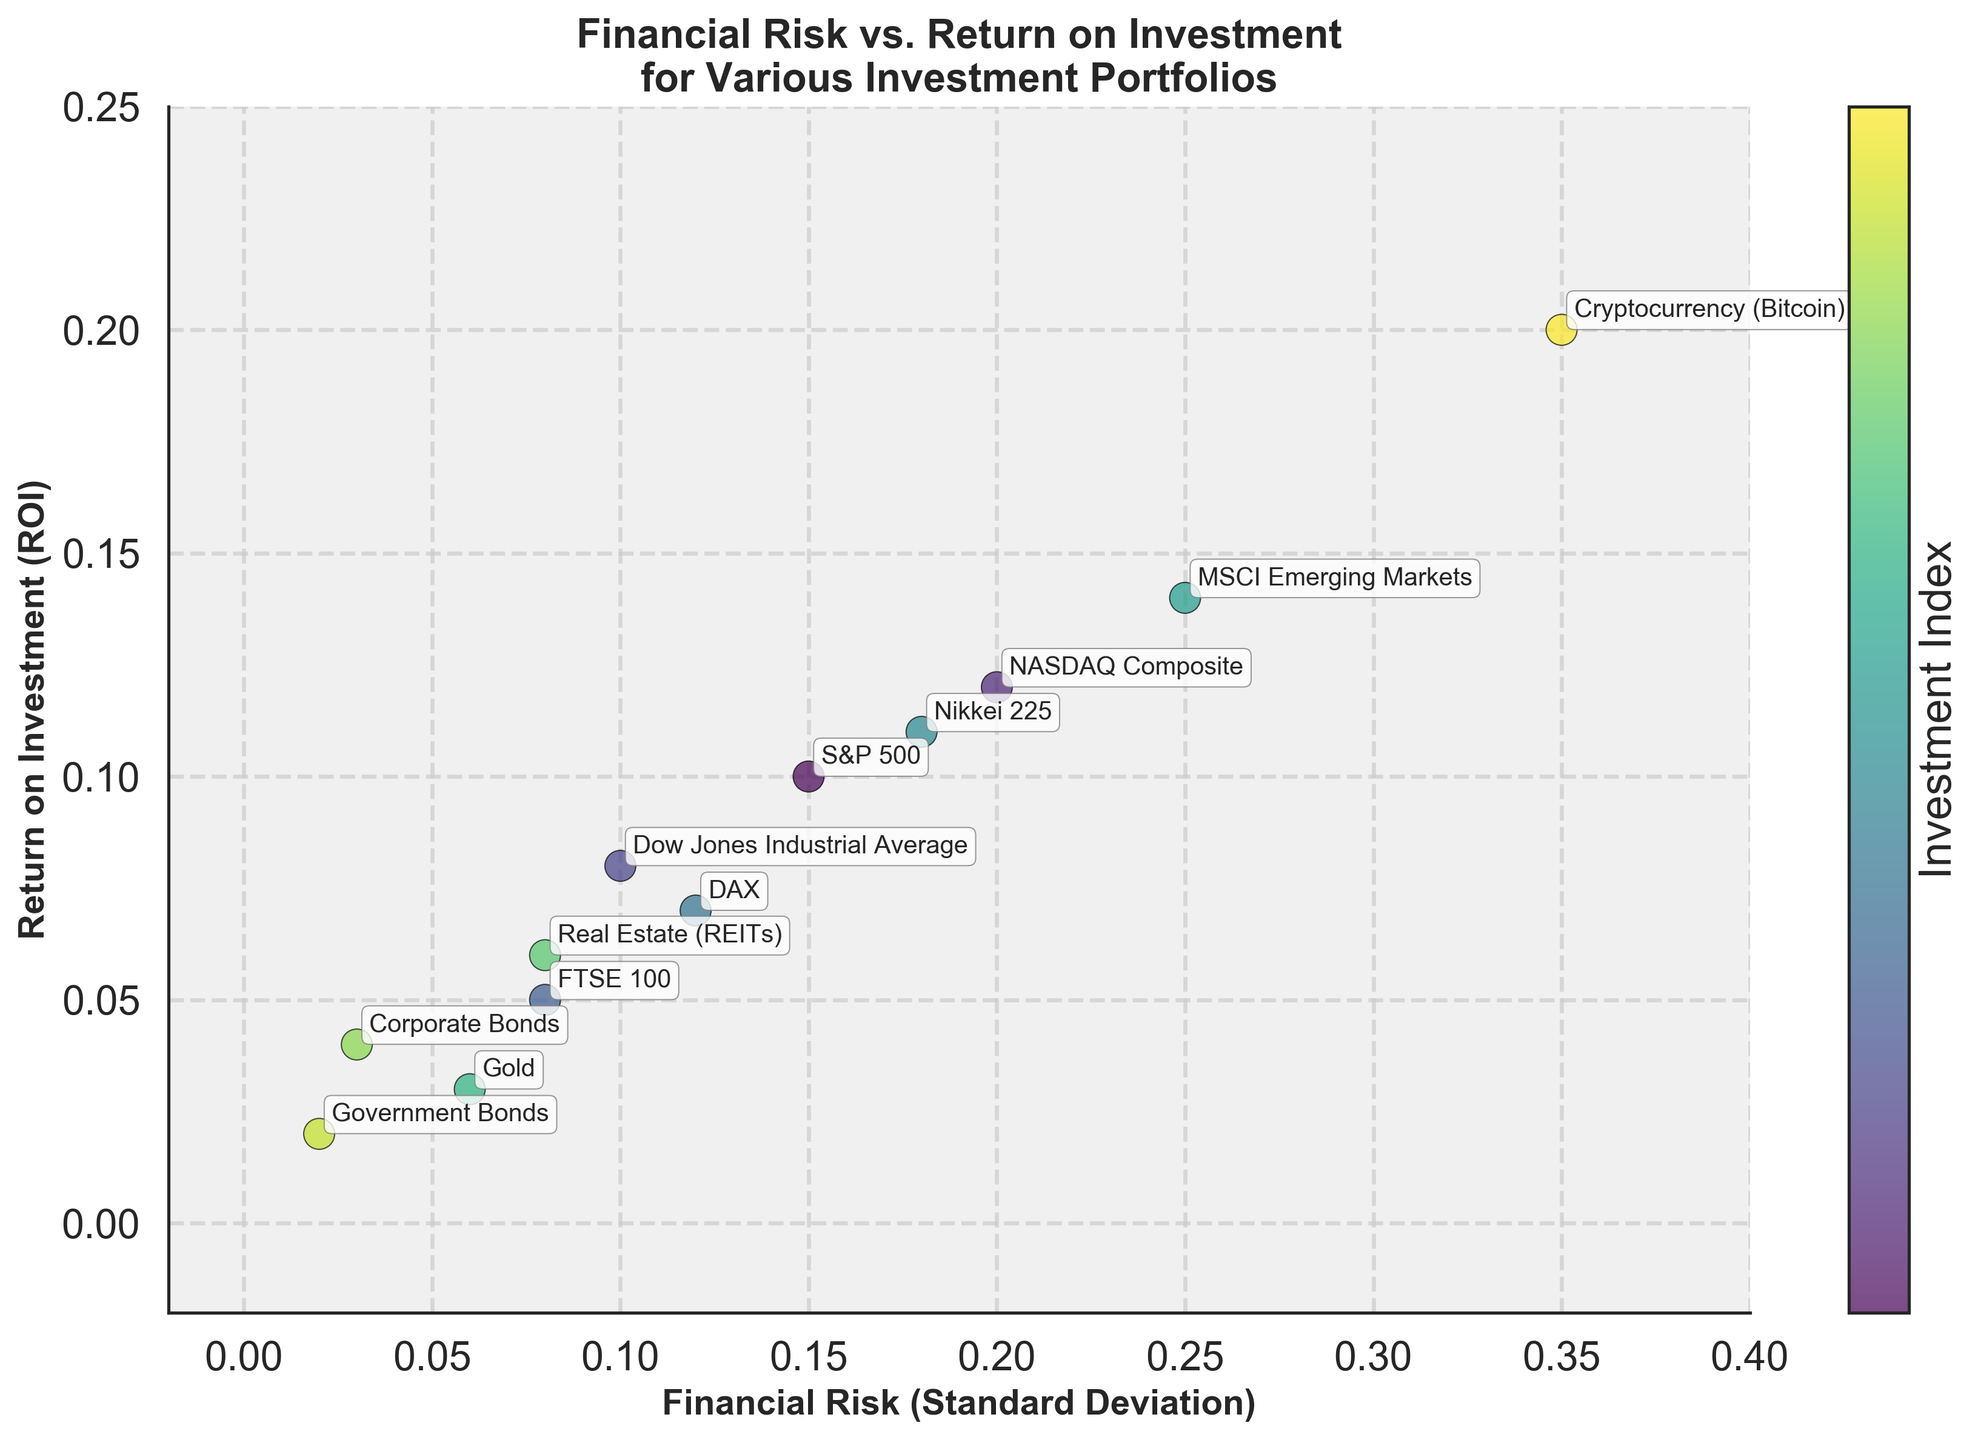What is the title of the plot? The title of the plot is written at the top center of the figure. It summarizes what the plot is about. It is "Financial Risk vs. Return on Investment for Various Investment Portfolios".
Answer: Financial Risk vs. Return on Investment for Various Investment Portfolios How many investment portfolios are represented in the plot? Count each unique data point labeled with the investment names. There are 12 labels visible, indicating 12 different investment portfolios.
Answer: 12 Which investment has the highest financial risk? By looking at the x-axis (Financial Risk), find the data point that is positioned the farthest to the right. It's labeled "Cryptocurrency (Bitcoin)" with a financial risk of 0.35.
Answer: Cryptocurrency (Bitcoin) What are the Financial Risk and ROI of the investment with the lowest ROI? Compare all the data points along the y-axis (ROI) and find the lowest point. This point is labeled "Government Bonds" at 0.02 ROI and 0.02 Financial Risk.
Answer: Financial Risk: 0.02, ROI: 0.02 Which investment portfolios have a financial risk of 0.08? Identify the data points aligned vertically at x = 0.08 on the Financial Risk axis. They are labeled "FTSE 100" and "Real Estate (REITs)".
Answer: FTSE 100 and Real Estate (REITs) Which investment offers a better return for a similar financial risk: FTSE 100 or Real Estate (REITs)? Both investments have a financial risk of 0.08. Compare their Return on Investment values on the y-axis. FTSE 100 has a ROI of 0.05, while Real Estate (REITs) has a higher ROI of 0.06.
Answer: Real Estate (REITs) Among investments with a financial risk below 0.10, which one has the highest ROI? Find the data points on the plot with financial risks less than 0.10 and compare their ROI. Corporate Bonds (0.04 ROI) and Gold (0.03 ROI) fit this criterion. Corporate Bonds offers the highest ROI among them.
Answer: Corporate Bonds What is the range of Financial Risk values for all the investments in this plot? The smallest and largest Financial Risk values are seen on the x-axis. The minimum is by Government Bonds at 0.02, and the maximum is by Cryptocurrency (Bitcoin) at 0.35. So, the range is 0.35 - 0.02.
Answer: 0.33 If you want to minimize risk while getting at least a 0.05 ROI, which investments should be considered? Find the investments with ROIs ≥ 0.05 and among those, select the ones with the smallest financial risks. Qualified are FTSE 100 (0.08 risk) and Real Estate (REITs) (also 0.08 risk).
Answer: FTSE 100 and Real Estate (REITs) What general trend can be observed between Financial Risk and ROI across the investments? Observe the overall arrangement of the data points. Generally, as the Financial Risk on the x-axis increases, the ROI on the y-axis also tends to increase, suggesting a positive relationship between risk and return.
Answer: Higher risk tends to correlate with higher ROI 